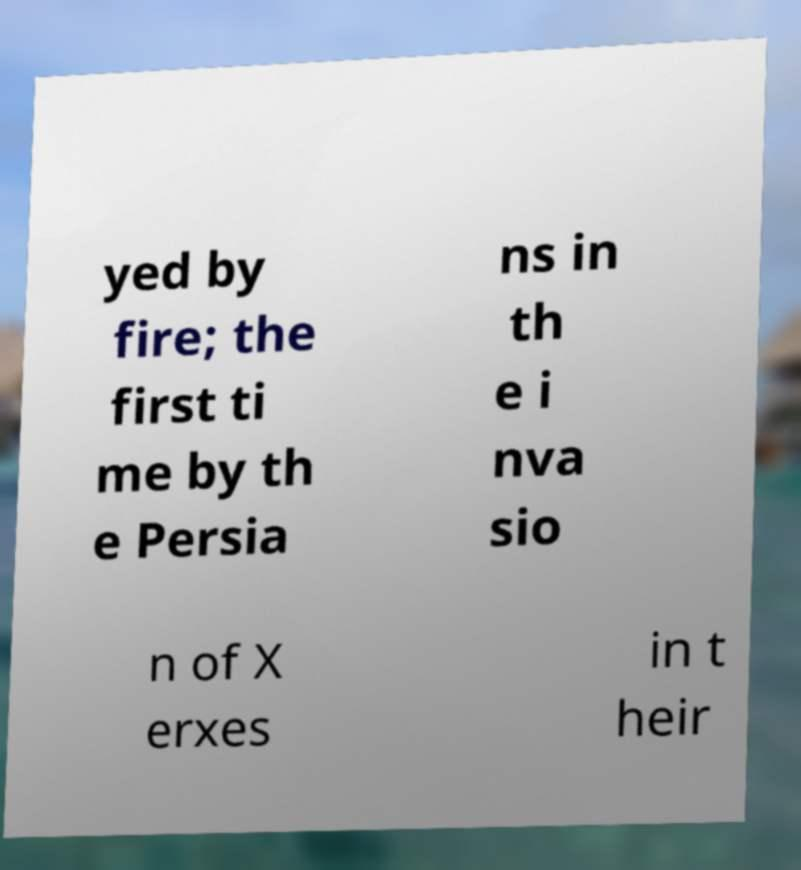What messages or text are displayed in this image? I need them in a readable, typed format. yed by fire; the first ti me by th e Persia ns in th e i nva sio n of X erxes in t heir 